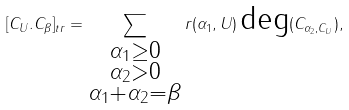Convert formula to latex. <formula><loc_0><loc_0><loc_500><loc_500>[ C _ { U } . C _ { \beta } ] _ { t r } = \sum _ { \substack { \alpha _ { 1 } \geq 0 \\ \alpha _ { 2 } > 0 \\ \alpha _ { 1 } + \alpha _ { 2 } = \beta } } r ( \alpha _ { 1 } , U ) \, \text {deg} ( C _ { \alpha _ { 2 } , C _ { U } } ) ,</formula> 